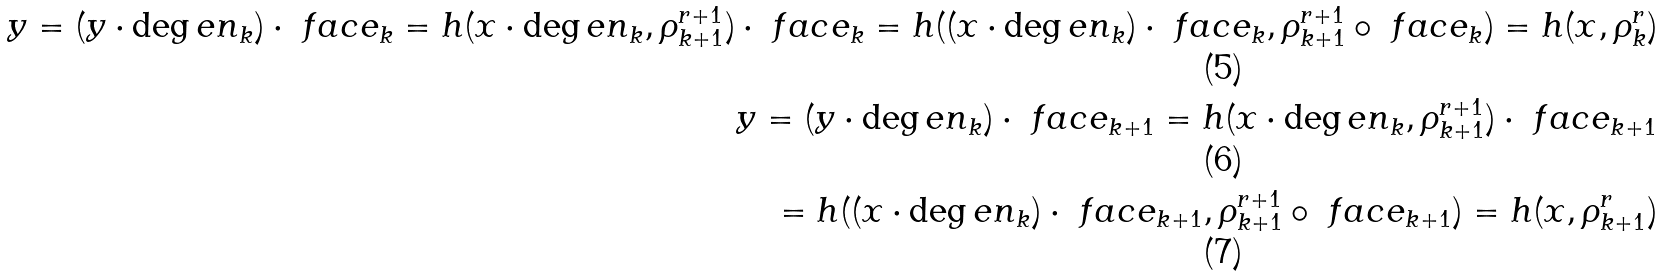Convert formula to latex. <formula><loc_0><loc_0><loc_500><loc_500>y = ( y \cdot \deg e n _ { k } ) \cdot \ f a c e _ { k } = h ( x \cdot \deg e n _ { k } , \rho ^ { r + 1 } _ { k + 1 } ) \cdot \ f a c e _ { k } = h ( ( x \cdot \deg e n _ { k } ) \cdot \ f a c e _ { k } , \rho ^ { r + 1 } _ { k + 1 } \circ \ f a c e _ { k } ) = h ( x , \rho ^ { r } _ { k } ) \\ y = ( y \cdot \deg e n _ { k } ) \cdot \ f a c e _ { k + 1 } = h ( x \cdot \deg e n _ { k } , \rho ^ { r + 1 } _ { k + 1 } ) \cdot \ f a c e _ { k + 1 } \\ = h ( ( x \cdot \deg e n _ { k } ) \cdot \ f a c e _ { k + 1 } , \rho ^ { r + 1 } _ { k + 1 } \circ \ f a c e _ { k + 1 } ) = h ( x , \rho ^ { r } _ { k + 1 } )</formula> 